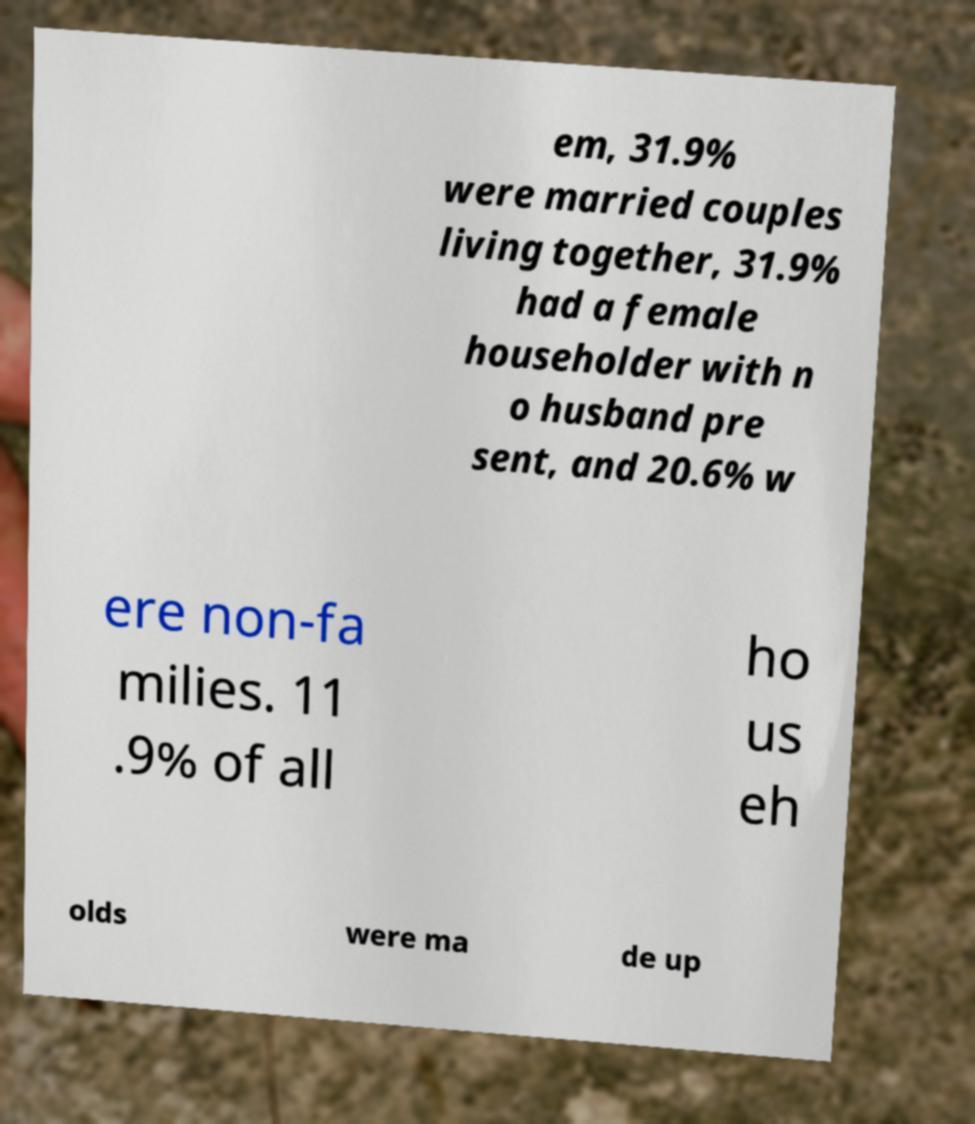There's text embedded in this image that I need extracted. Can you transcribe it verbatim? em, 31.9% were married couples living together, 31.9% had a female householder with n o husband pre sent, and 20.6% w ere non-fa milies. 11 .9% of all ho us eh olds were ma de up 